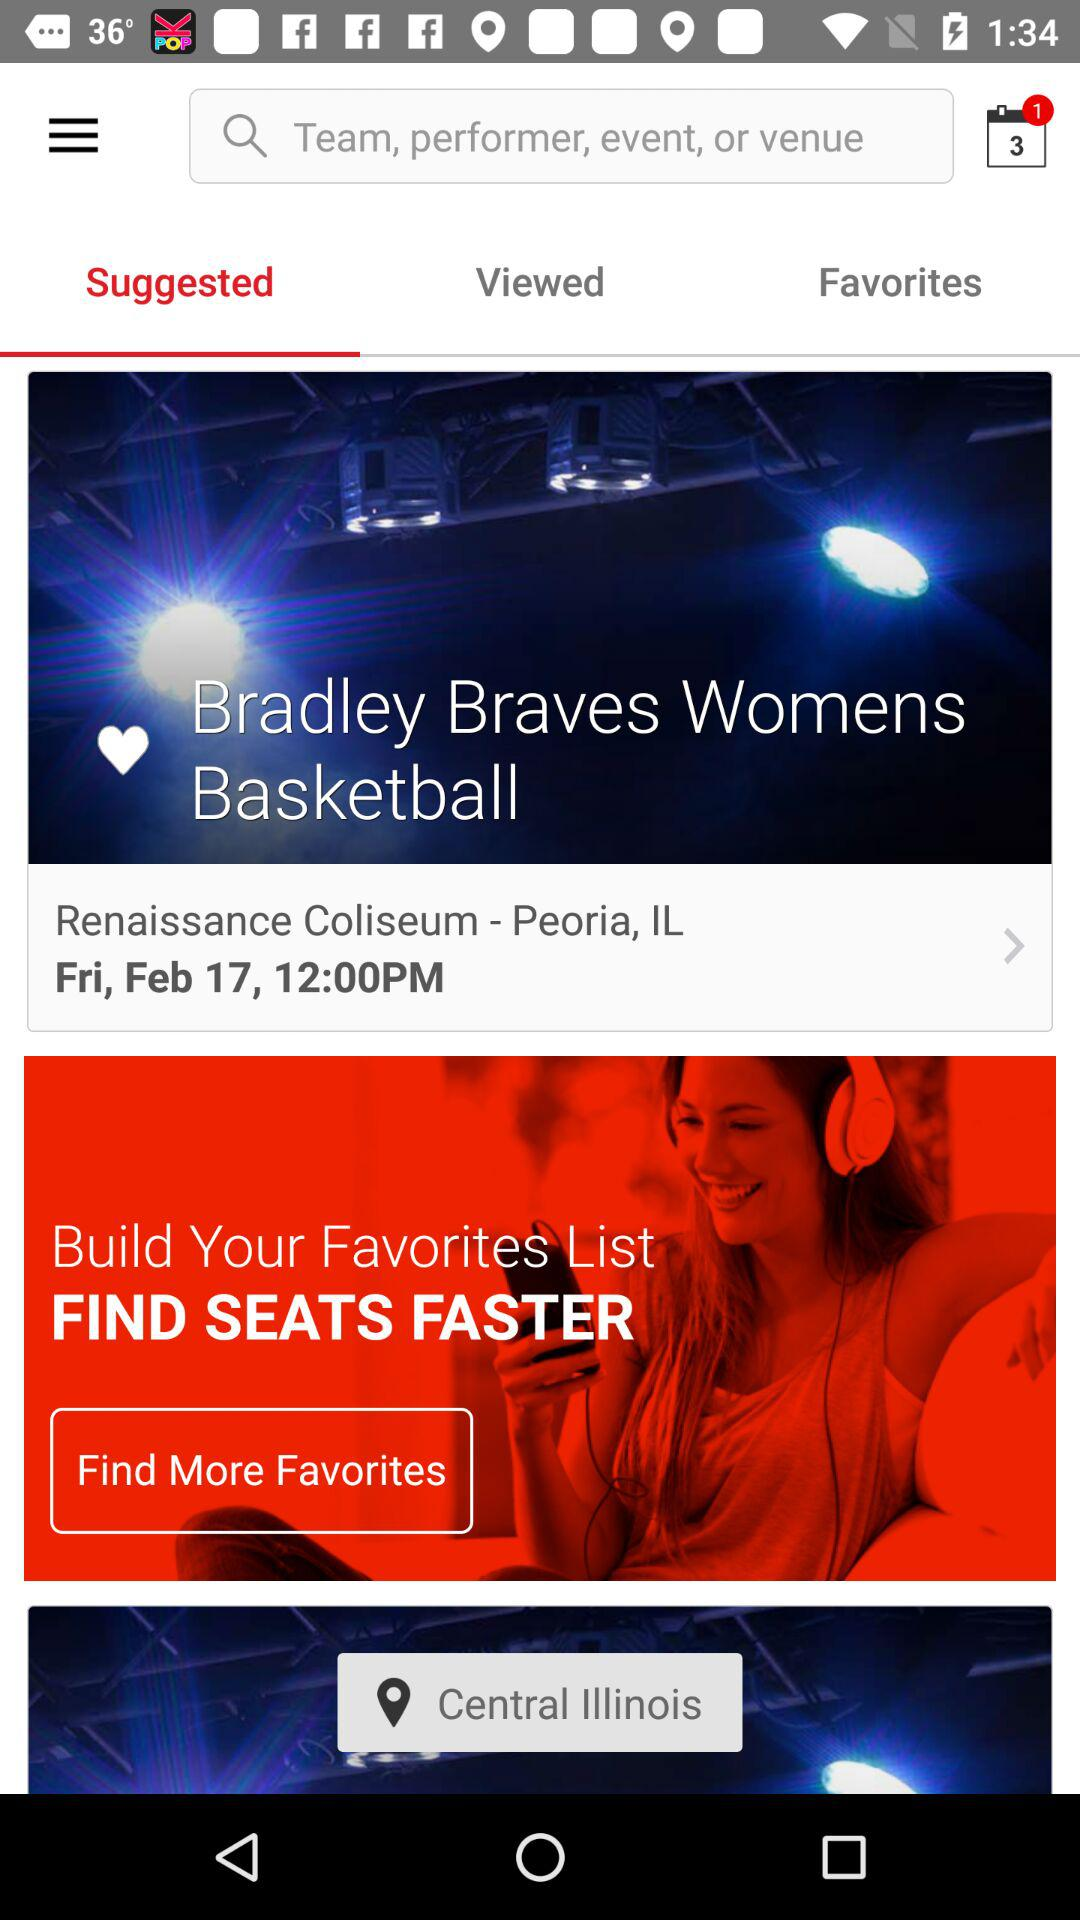What's the event date and time? The event date and time are Friday, February 17 at 12:00 PM. 